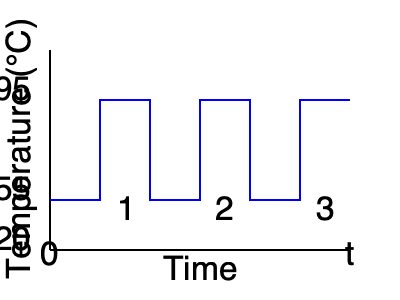Analyze the temperature-time graph of a PCR cycle. Which step of the PCR process occurs at 55°C, and what is its primary function in DNA amplification? To answer this question, let's break down the PCR cycle and its temperature-dependent steps:

1. The graph shows three distinct temperature stages in a PCR cycle:
   a) 95°C
   b) 55°C
   c) 72°C (not labeled, but typically between 70-75°C)

2. These temperatures correspond to the three main steps of PCR:
   a) Denaturation (95°C): DNA strands separate
   b) Annealing (55°C): Primers bind to single-stranded DNA
   c) Extension (72°C): DNA polymerase synthesizes new strands

3. The question asks specifically about the 55°C step, which is the annealing step.

4. During annealing:
   - The temperature is lowered to allow primers to bind (anneal) to complementary sequences on the single-stranded DNA templates.
   - This step is crucial for initiating DNA synthesis, as it provides a starting point for DNA polymerase.

5. The primary function of the annealing step in DNA amplification is:
   - To position primers at specific locations on the template DNA.
   - This ensures that only the desired DNA region (between the two primers) is amplified.
   - It provides the 3' end for DNA polymerase to begin extension in the next step.

Therefore, the 55°C step represents the annealing phase, which is essential for specific and targeted DNA amplification in PCR.
Answer: Annealing; primer binding to template DNA 